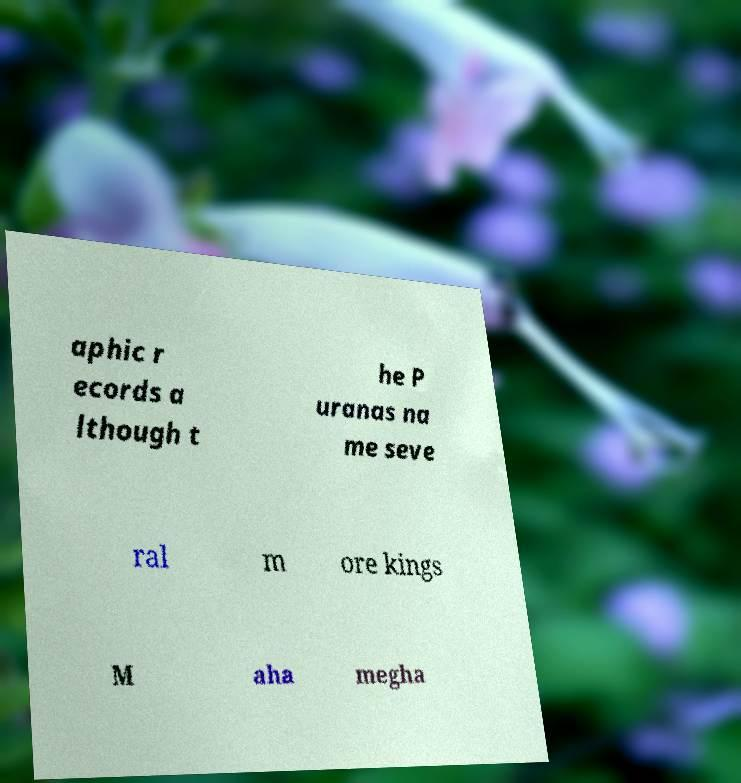Please identify and transcribe the text found in this image. aphic r ecords a lthough t he P uranas na me seve ral m ore kings M aha megha 